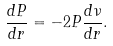<formula> <loc_0><loc_0><loc_500><loc_500>\frac { d P } { d r } = - 2 P \frac { d \nu } { d r } .</formula> 